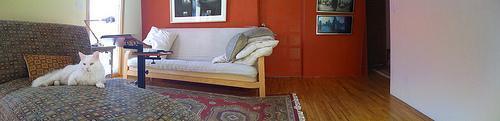How many cats are laying down?
Give a very brief answer. 1. How many couches are there?
Give a very brief answer. 1. How many rugs are on the floor?
Give a very brief answer. 1. 